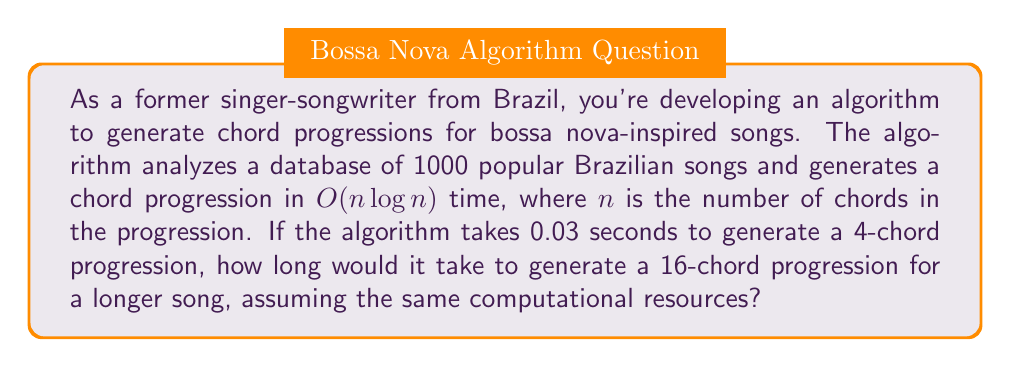Help me with this question. Let's approach this step-by-step:

1) The algorithm's time complexity is $O(n \log n)$, where $n$ is the number of chords.

2) We're given that for $n_1 = 4$ chords, the time taken is $t_1 = 0.03$ seconds.

3) We need to find the time $t_2$ for $n_2 = 16$ chords.

4) In Big O notation, we can express the relationship as:

   $$\frac{t_1}{t_2} = \frac{n_1 \log n_1}{n_2 \log n_2}$$

5) Substituting the known values:

   $$\frac{0.03}{t_2} = \frac{4 \log 4}{16 \log 16}$$

6) Simplify:
   $$\frac{0.03}{t_2} = \frac{4 \cdot 2}{16 \cdot 4} = \frac{8}{64} = \frac{1}{8}$$

7) Solve for $t_2$:
   $$t_2 = 0.03 \cdot 8 = 0.24$$

Therefore, it would take 0.24 seconds to generate a 16-chord progression.
Answer: 0.24 seconds 